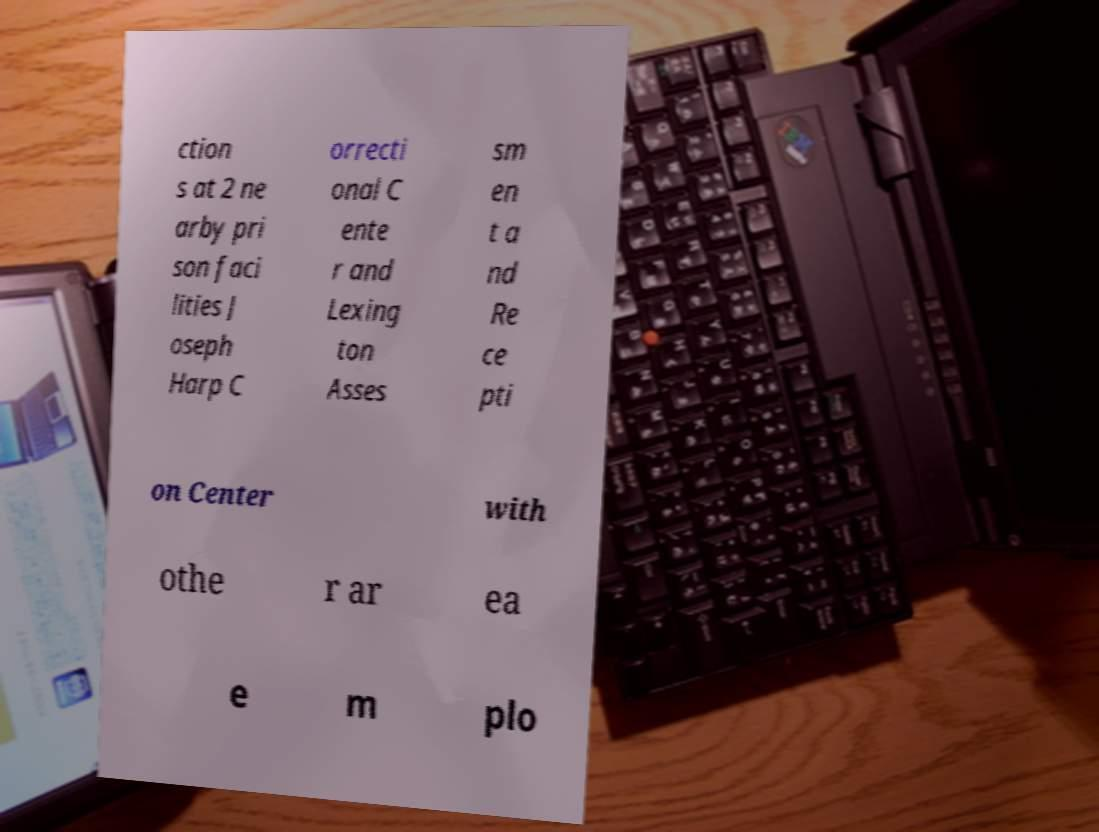Can you read and provide the text displayed in the image?This photo seems to have some interesting text. Can you extract and type it out for me? ction s at 2 ne arby pri son faci lities J oseph Harp C orrecti onal C ente r and Lexing ton Asses sm en t a nd Re ce pti on Center with othe r ar ea e m plo 